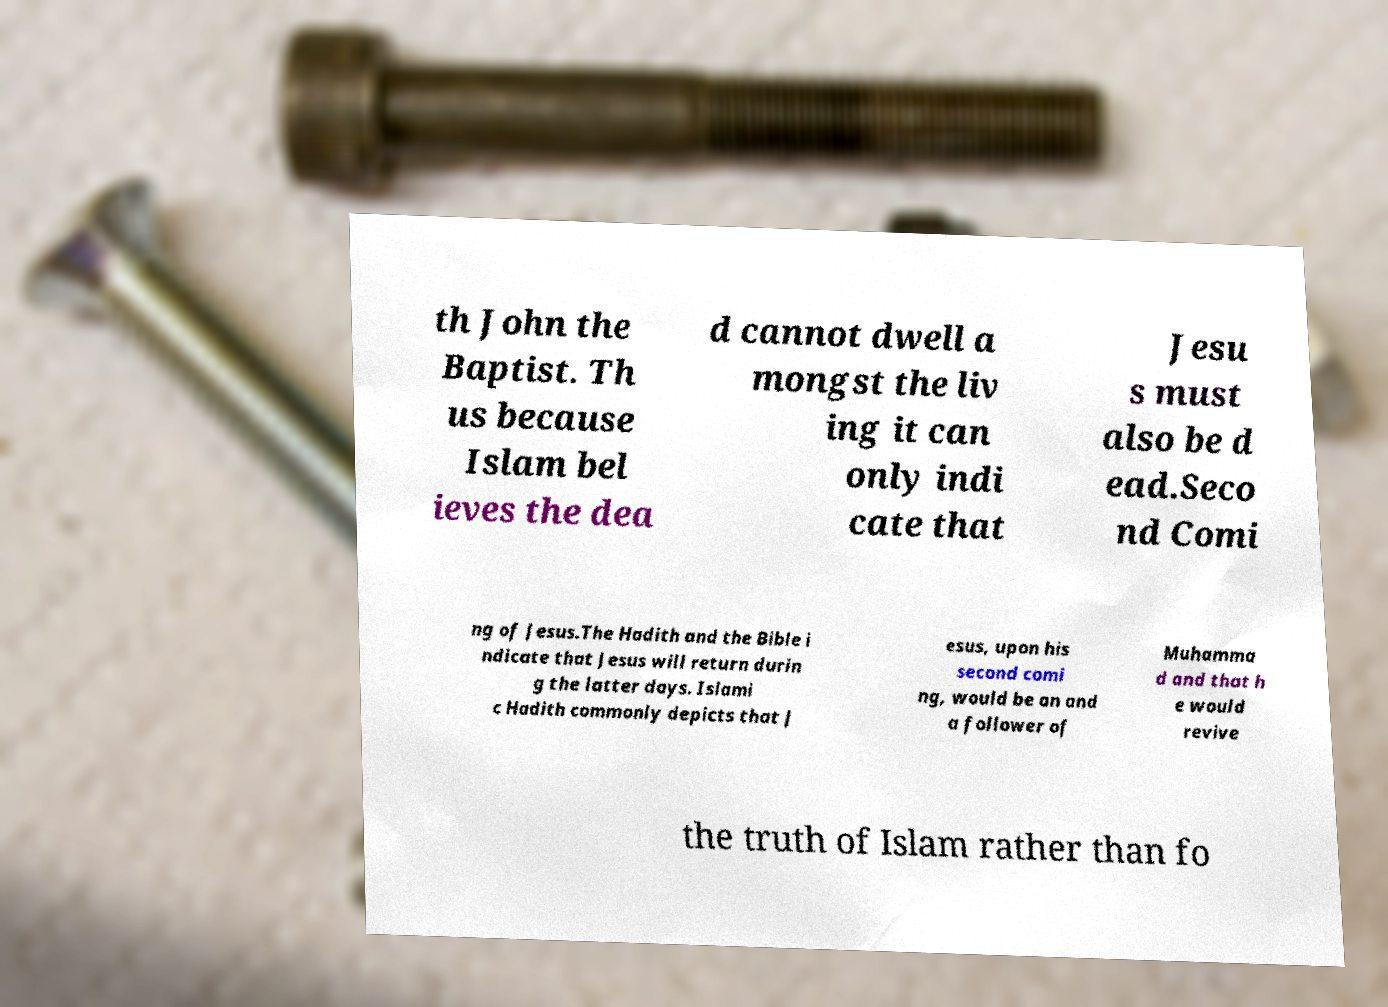What messages or text are displayed in this image? I need them in a readable, typed format. th John the Baptist. Th us because Islam bel ieves the dea d cannot dwell a mongst the liv ing it can only indi cate that Jesu s must also be d ead.Seco nd Comi ng of Jesus.The Hadith and the Bible i ndicate that Jesus will return durin g the latter days. Islami c Hadith commonly depicts that J esus, upon his second comi ng, would be an and a follower of Muhamma d and that h e would revive the truth of Islam rather than fo 